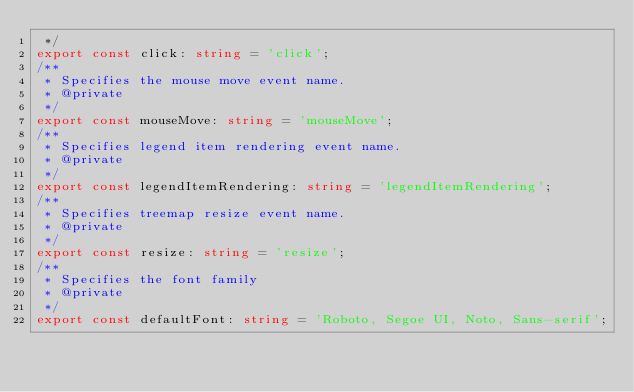<code> <loc_0><loc_0><loc_500><loc_500><_TypeScript_> */
export const click: string = 'click';
/**
 * Specifies the mouse move event name.
 * @private
 */
export const mouseMove: string = 'mouseMove';
/**
 * Specifies legend item rendering event name.
 * @private
 */
export const legendItemRendering: string = 'legendItemRendering';
/**
 * Specifies treemap resize event name.
 * @private
 */
export const resize: string = 'resize';
/**
 * Specifies the font family
 * @private
 */
export const defaultFont: string = 'Roboto, Segoe UI, Noto, Sans-serif';</code> 